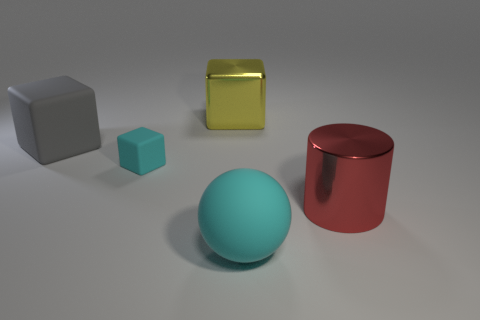What can we infer about the size of the objects relative to each other? From observing the scene, we can infer that the objects vary in size. The red cylinder and the gray cube appear to be the largest. The gold box is slightly smaller in height compared to these two, yet still considerable in size. The turquoise cube is notably smaller than the other objects, and this scale difference is accentuated by the positioning and perspective of the objects within the scene. 